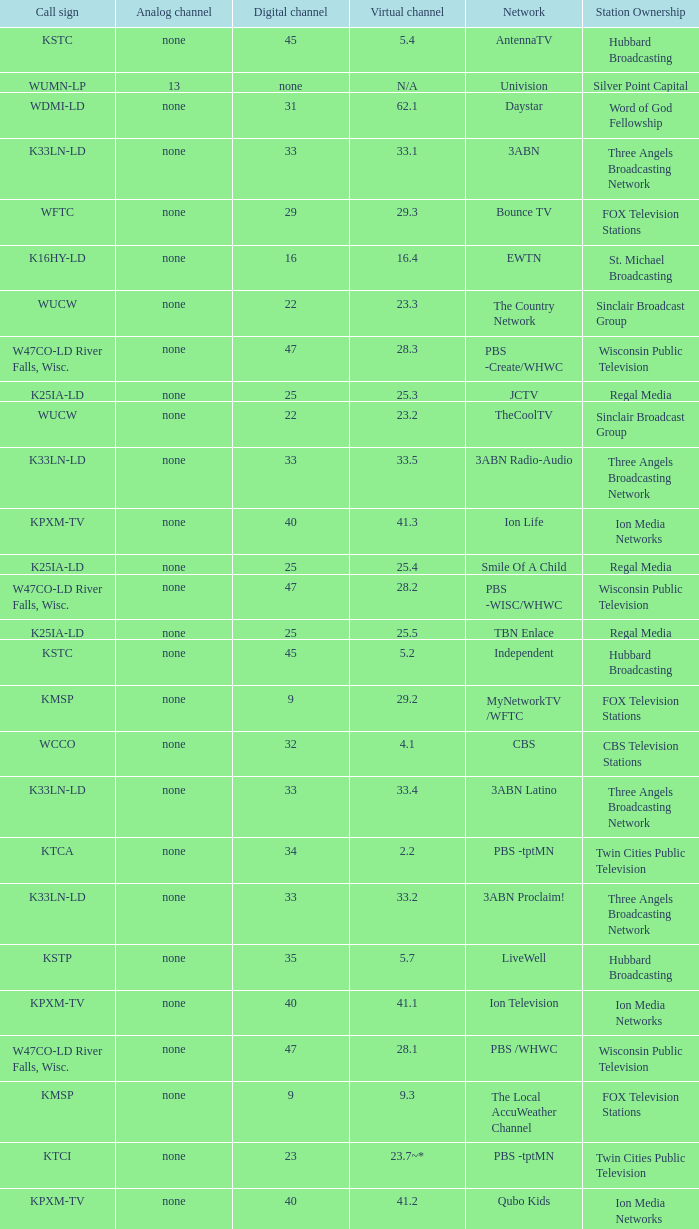Network of nbc is what digital channel? 11.0. 